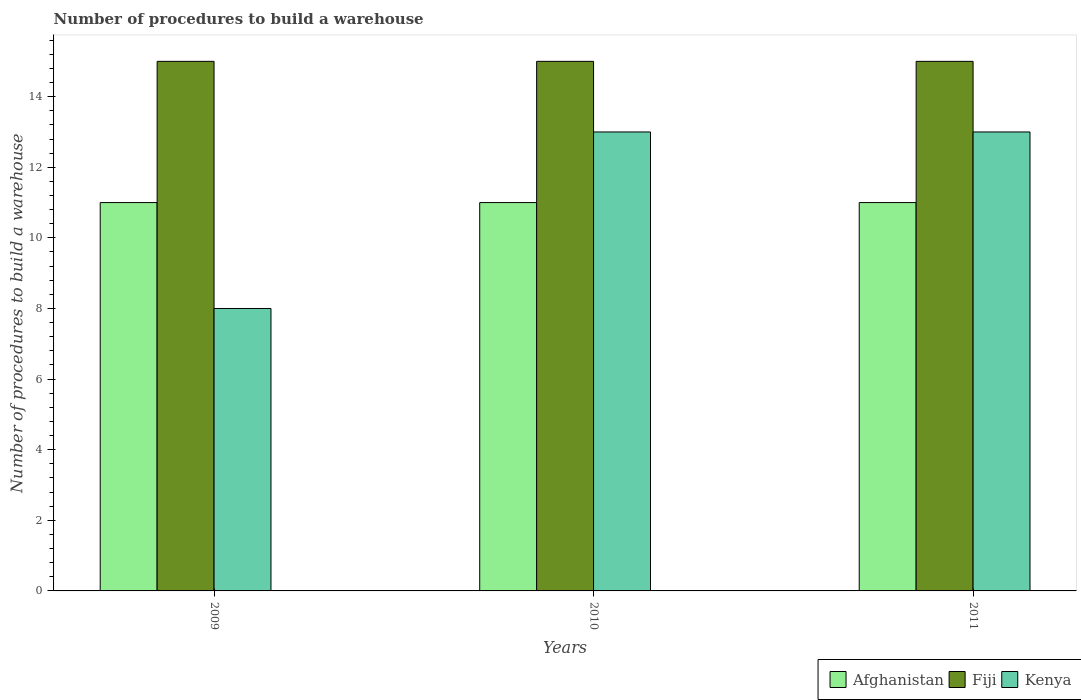How many groups of bars are there?
Ensure brevity in your answer.  3. Are the number of bars per tick equal to the number of legend labels?
Your response must be concise. Yes. How many bars are there on the 1st tick from the left?
Provide a short and direct response. 3. What is the label of the 3rd group of bars from the left?
Ensure brevity in your answer.  2011. In how many cases, is the number of bars for a given year not equal to the number of legend labels?
Give a very brief answer. 0. What is the number of procedures to build a warehouse in in Afghanistan in 2009?
Offer a very short reply. 11. Across all years, what is the maximum number of procedures to build a warehouse in in Afghanistan?
Offer a terse response. 11. Across all years, what is the minimum number of procedures to build a warehouse in in Afghanistan?
Your response must be concise. 11. In which year was the number of procedures to build a warehouse in in Afghanistan maximum?
Provide a succinct answer. 2009. In which year was the number of procedures to build a warehouse in in Kenya minimum?
Give a very brief answer. 2009. What is the total number of procedures to build a warehouse in in Afghanistan in the graph?
Offer a very short reply. 33. What is the difference between the number of procedures to build a warehouse in in Afghanistan in 2010 and that in 2011?
Provide a short and direct response. 0. What is the difference between the number of procedures to build a warehouse in in Kenya in 2011 and the number of procedures to build a warehouse in in Fiji in 2010?
Offer a terse response. -2. In the year 2011, what is the difference between the number of procedures to build a warehouse in in Fiji and number of procedures to build a warehouse in in Afghanistan?
Offer a terse response. 4. In how many years, is the number of procedures to build a warehouse in in Fiji greater than 13.2?
Make the answer very short. 3. What is the ratio of the number of procedures to build a warehouse in in Kenya in 2009 to that in 2010?
Your response must be concise. 0.62. Is the number of procedures to build a warehouse in in Fiji in 2009 less than that in 2011?
Offer a terse response. No. Is the difference between the number of procedures to build a warehouse in in Fiji in 2010 and 2011 greater than the difference between the number of procedures to build a warehouse in in Afghanistan in 2010 and 2011?
Your answer should be compact. No. What is the difference between the highest and the second highest number of procedures to build a warehouse in in Kenya?
Provide a succinct answer. 0. What is the difference between the highest and the lowest number of procedures to build a warehouse in in Kenya?
Your response must be concise. 5. In how many years, is the number of procedures to build a warehouse in in Fiji greater than the average number of procedures to build a warehouse in in Fiji taken over all years?
Your answer should be very brief. 0. Is the sum of the number of procedures to build a warehouse in in Kenya in 2010 and 2011 greater than the maximum number of procedures to build a warehouse in in Afghanistan across all years?
Ensure brevity in your answer.  Yes. What does the 1st bar from the left in 2011 represents?
Ensure brevity in your answer.  Afghanistan. What does the 1st bar from the right in 2010 represents?
Keep it short and to the point. Kenya. How many bars are there?
Offer a very short reply. 9. Are all the bars in the graph horizontal?
Your answer should be compact. No. Where does the legend appear in the graph?
Give a very brief answer. Bottom right. What is the title of the graph?
Make the answer very short. Number of procedures to build a warehouse. What is the label or title of the X-axis?
Ensure brevity in your answer.  Years. What is the label or title of the Y-axis?
Make the answer very short. Number of procedures to build a warehouse. What is the Number of procedures to build a warehouse in Afghanistan in 2009?
Your response must be concise. 11. What is the Number of procedures to build a warehouse of Fiji in 2010?
Give a very brief answer. 15. What is the Number of procedures to build a warehouse of Kenya in 2010?
Your answer should be very brief. 13. What is the Number of procedures to build a warehouse in Afghanistan in 2011?
Keep it short and to the point. 11. What is the Number of procedures to build a warehouse of Fiji in 2011?
Make the answer very short. 15. Across all years, what is the maximum Number of procedures to build a warehouse of Afghanistan?
Offer a very short reply. 11. Across all years, what is the maximum Number of procedures to build a warehouse in Fiji?
Keep it short and to the point. 15. Across all years, what is the minimum Number of procedures to build a warehouse of Fiji?
Provide a succinct answer. 15. What is the total Number of procedures to build a warehouse in Afghanistan in the graph?
Give a very brief answer. 33. What is the total Number of procedures to build a warehouse of Fiji in the graph?
Offer a very short reply. 45. What is the difference between the Number of procedures to build a warehouse of Afghanistan in 2009 and that in 2010?
Ensure brevity in your answer.  0. What is the difference between the Number of procedures to build a warehouse in Kenya in 2009 and that in 2010?
Offer a terse response. -5. What is the difference between the Number of procedures to build a warehouse in Afghanistan in 2009 and that in 2011?
Keep it short and to the point. 0. What is the difference between the Number of procedures to build a warehouse in Fiji in 2009 and that in 2011?
Make the answer very short. 0. What is the difference between the Number of procedures to build a warehouse of Fiji in 2010 and that in 2011?
Provide a short and direct response. 0. What is the difference between the Number of procedures to build a warehouse of Kenya in 2010 and that in 2011?
Offer a terse response. 0. What is the difference between the Number of procedures to build a warehouse in Afghanistan in 2009 and the Number of procedures to build a warehouse in Kenya in 2011?
Offer a terse response. -2. What is the difference between the Number of procedures to build a warehouse of Fiji in 2009 and the Number of procedures to build a warehouse of Kenya in 2011?
Provide a succinct answer. 2. What is the difference between the Number of procedures to build a warehouse of Afghanistan in 2010 and the Number of procedures to build a warehouse of Fiji in 2011?
Make the answer very short. -4. What is the difference between the Number of procedures to build a warehouse in Fiji in 2010 and the Number of procedures to build a warehouse in Kenya in 2011?
Keep it short and to the point. 2. What is the average Number of procedures to build a warehouse in Kenya per year?
Make the answer very short. 11.33. In the year 2009, what is the difference between the Number of procedures to build a warehouse of Afghanistan and Number of procedures to build a warehouse of Fiji?
Ensure brevity in your answer.  -4. In the year 2009, what is the difference between the Number of procedures to build a warehouse in Fiji and Number of procedures to build a warehouse in Kenya?
Give a very brief answer. 7. In the year 2010, what is the difference between the Number of procedures to build a warehouse in Afghanistan and Number of procedures to build a warehouse in Fiji?
Your answer should be very brief. -4. In the year 2010, what is the difference between the Number of procedures to build a warehouse of Afghanistan and Number of procedures to build a warehouse of Kenya?
Your answer should be very brief. -2. What is the ratio of the Number of procedures to build a warehouse of Afghanistan in 2009 to that in 2010?
Provide a succinct answer. 1. What is the ratio of the Number of procedures to build a warehouse of Kenya in 2009 to that in 2010?
Ensure brevity in your answer.  0.62. What is the ratio of the Number of procedures to build a warehouse of Afghanistan in 2009 to that in 2011?
Ensure brevity in your answer.  1. What is the ratio of the Number of procedures to build a warehouse in Fiji in 2009 to that in 2011?
Keep it short and to the point. 1. What is the ratio of the Number of procedures to build a warehouse in Kenya in 2009 to that in 2011?
Make the answer very short. 0.62. What is the difference between the highest and the second highest Number of procedures to build a warehouse of Afghanistan?
Your answer should be compact. 0. What is the difference between the highest and the second highest Number of procedures to build a warehouse in Fiji?
Provide a succinct answer. 0. What is the difference between the highest and the lowest Number of procedures to build a warehouse in Fiji?
Give a very brief answer. 0. What is the difference between the highest and the lowest Number of procedures to build a warehouse of Kenya?
Give a very brief answer. 5. 